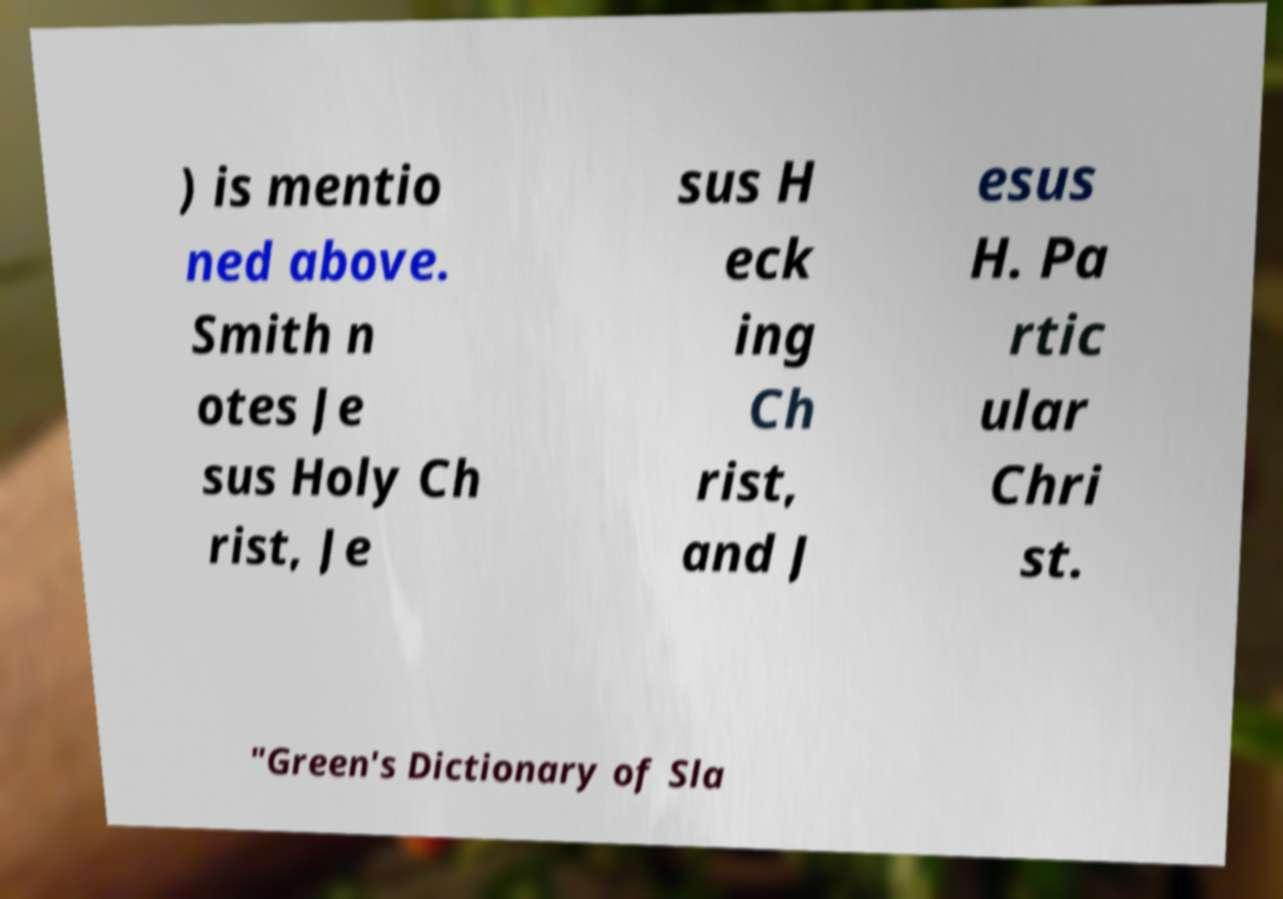There's text embedded in this image that I need extracted. Can you transcribe it verbatim? ) is mentio ned above. Smith n otes Je sus Holy Ch rist, Je sus H eck ing Ch rist, and J esus H. Pa rtic ular Chri st. "Green's Dictionary of Sla 